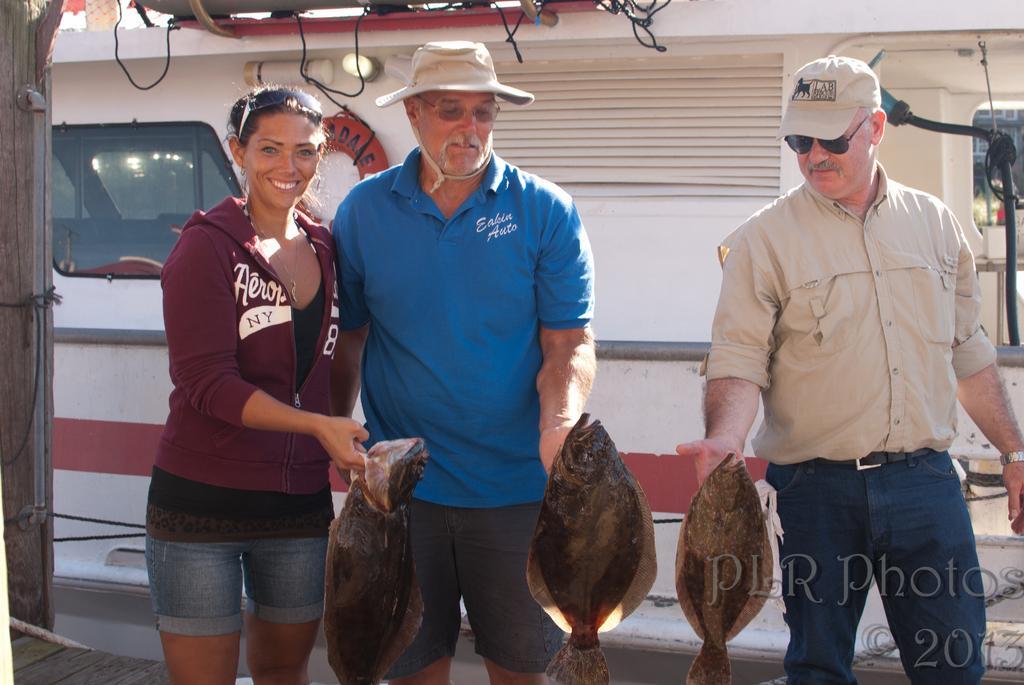Can you describe this image briefly? In this picture, we can see a few people holding fishes, and we can see the background with some objects like lights, glass, we can see ropes, a pole, ground, and some object in left side of the picture. 